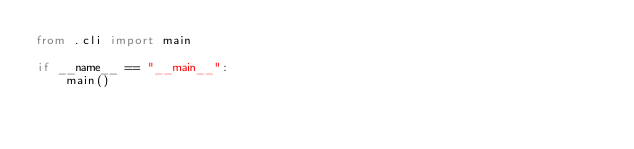Convert code to text. <code><loc_0><loc_0><loc_500><loc_500><_Python_>from .cli import main

if __name__ == "__main__":
    main()
</code> 